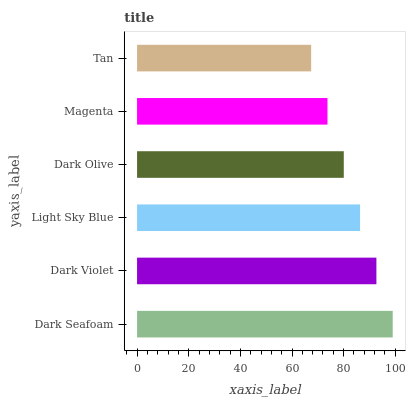Is Tan the minimum?
Answer yes or no. Yes. Is Dark Seafoam the maximum?
Answer yes or no. Yes. Is Dark Violet the minimum?
Answer yes or no. No. Is Dark Violet the maximum?
Answer yes or no. No. Is Dark Seafoam greater than Dark Violet?
Answer yes or no. Yes. Is Dark Violet less than Dark Seafoam?
Answer yes or no. Yes. Is Dark Violet greater than Dark Seafoam?
Answer yes or no. No. Is Dark Seafoam less than Dark Violet?
Answer yes or no. No. Is Light Sky Blue the high median?
Answer yes or no. Yes. Is Dark Olive the low median?
Answer yes or no. Yes. Is Dark Olive the high median?
Answer yes or no. No. Is Light Sky Blue the low median?
Answer yes or no. No. 